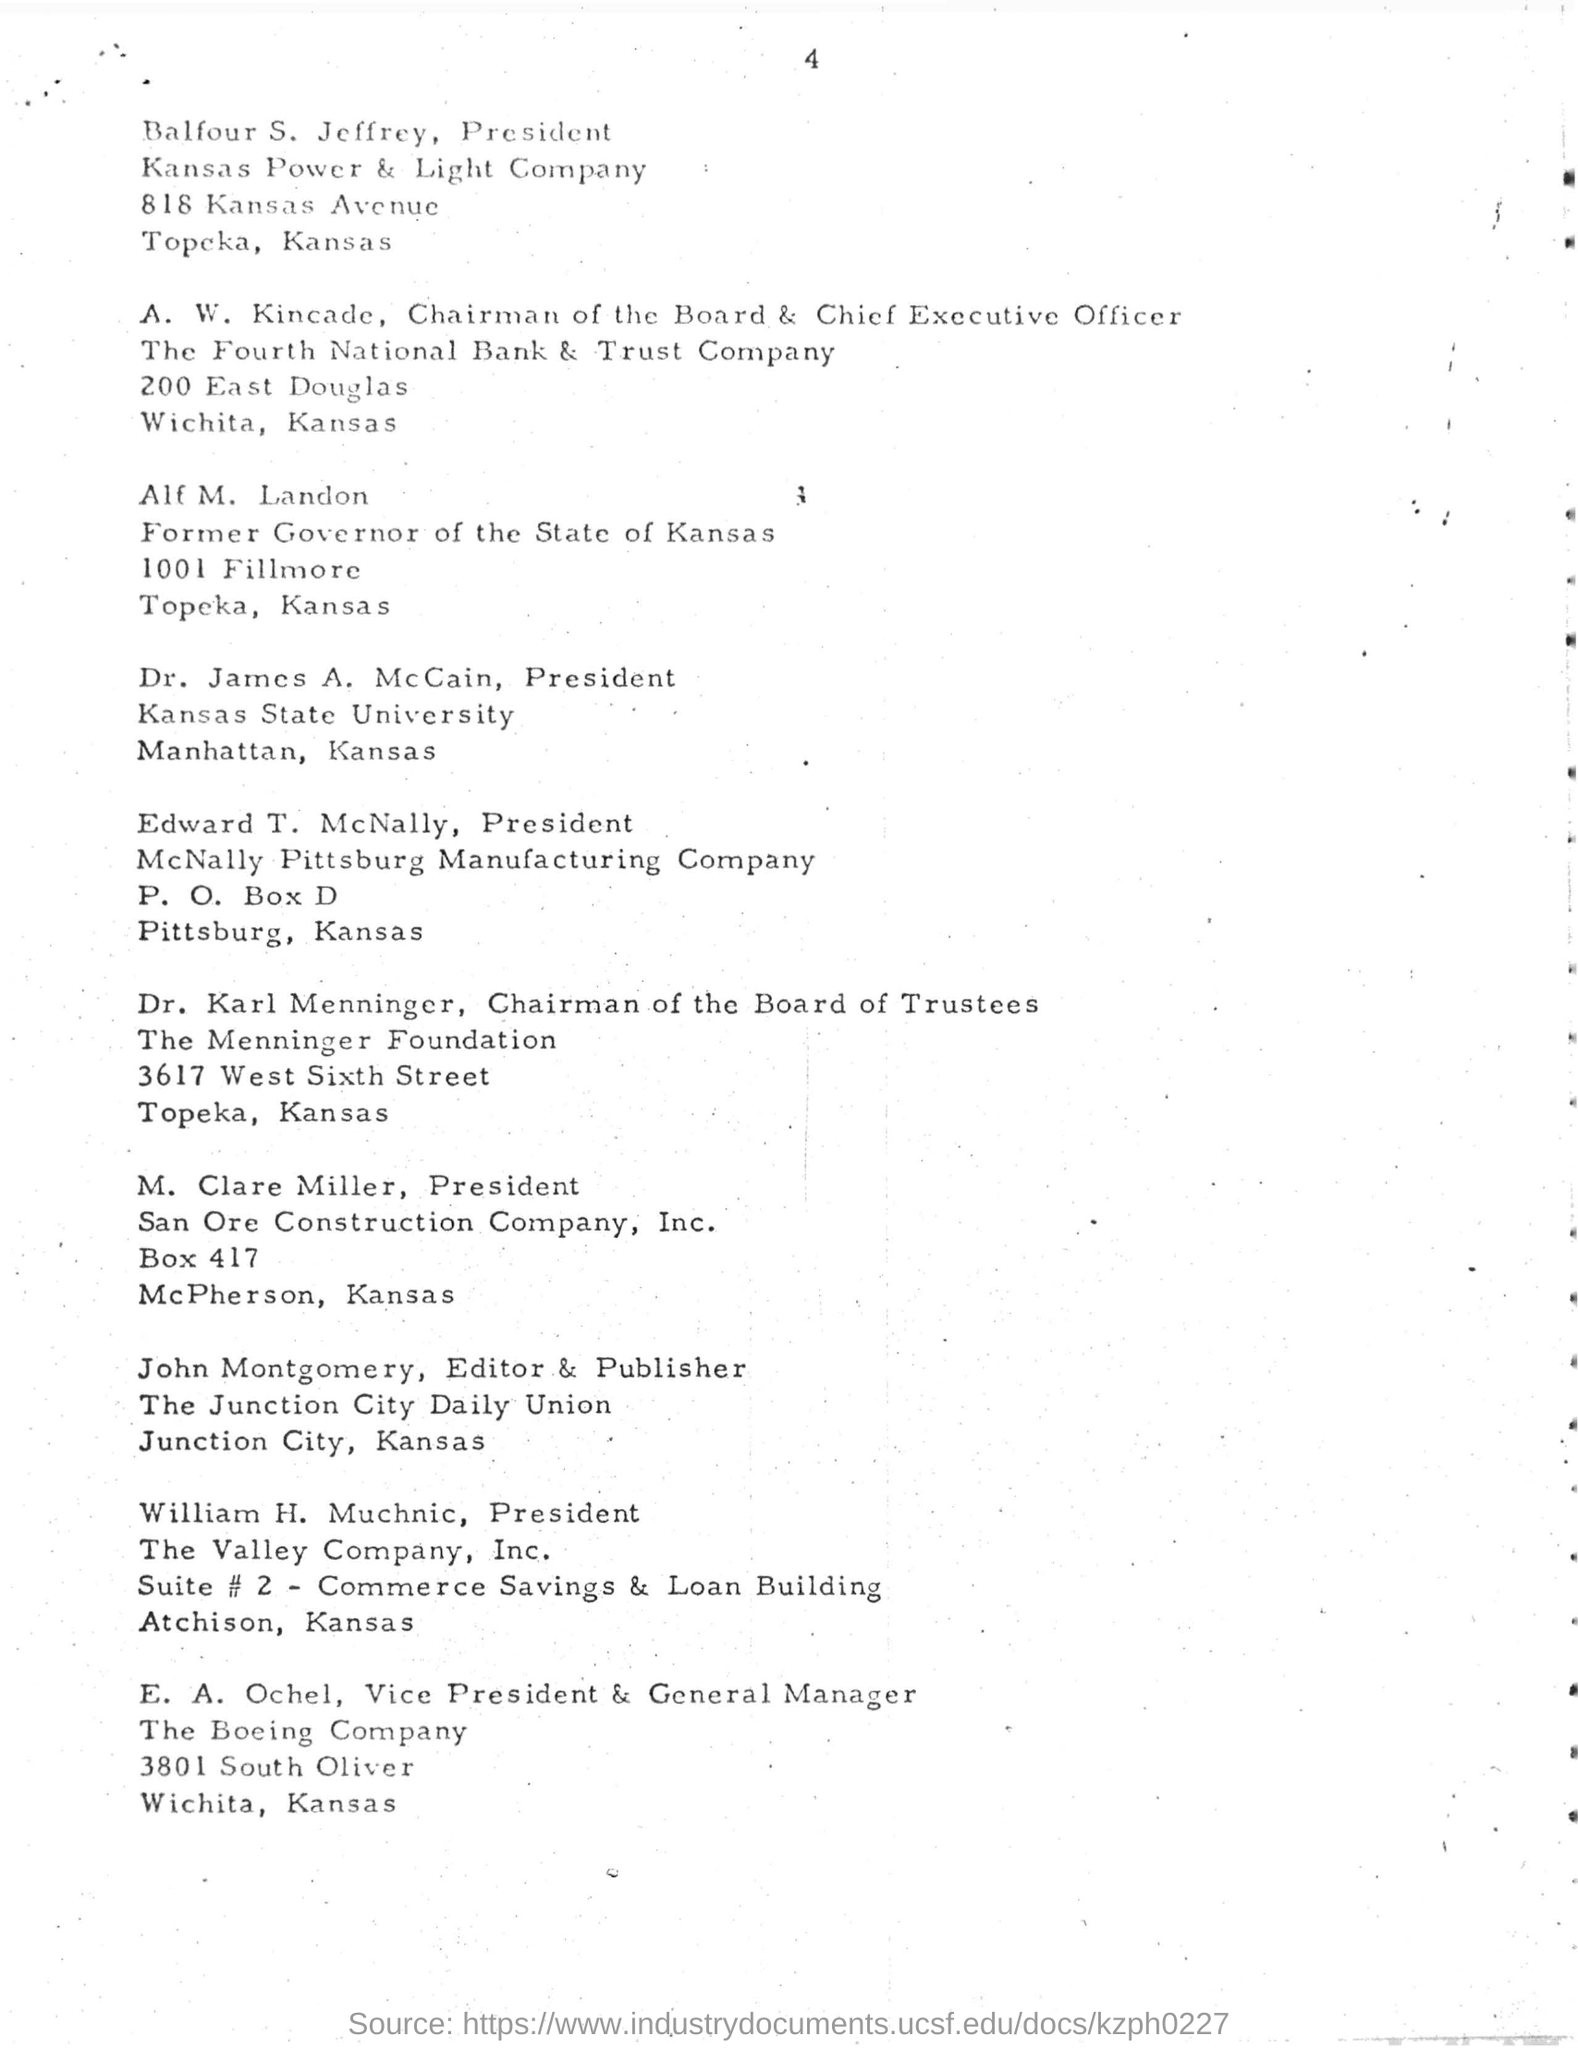Who is the President of Kansas Power & Light Company?
Ensure brevity in your answer.  Balfour S. Jeffrey. Who is the former governor of the state of Kansas?
Your response must be concise. Alf M. Landon. 